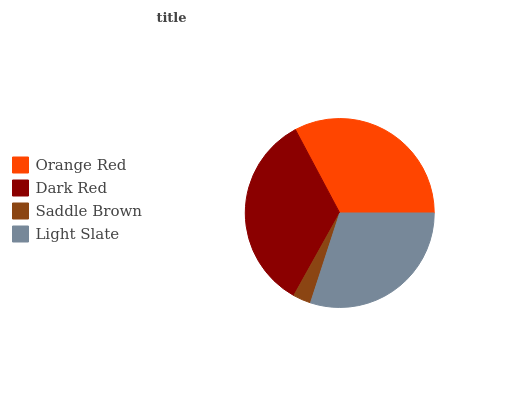Is Saddle Brown the minimum?
Answer yes or no. Yes. Is Dark Red the maximum?
Answer yes or no. Yes. Is Dark Red the minimum?
Answer yes or no. No. Is Saddle Brown the maximum?
Answer yes or no. No. Is Dark Red greater than Saddle Brown?
Answer yes or no. Yes. Is Saddle Brown less than Dark Red?
Answer yes or no. Yes. Is Saddle Brown greater than Dark Red?
Answer yes or no. No. Is Dark Red less than Saddle Brown?
Answer yes or no. No. Is Orange Red the high median?
Answer yes or no. Yes. Is Light Slate the low median?
Answer yes or no. Yes. Is Saddle Brown the high median?
Answer yes or no. No. Is Orange Red the low median?
Answer yes or no. No. 